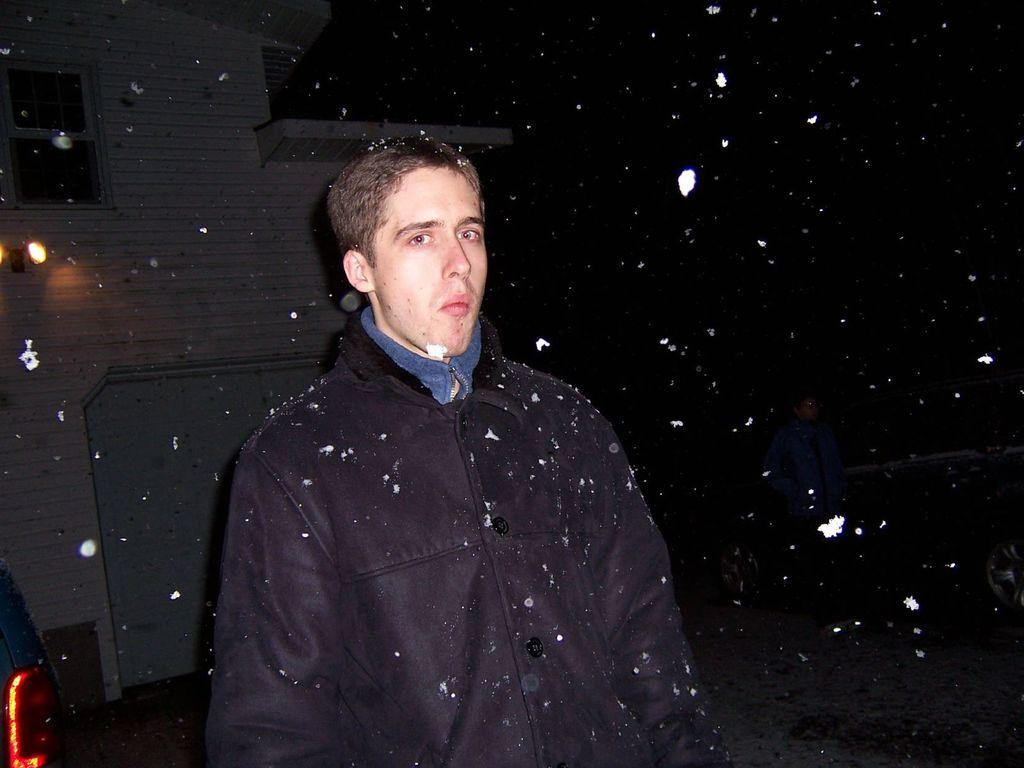Who can be seen in the image? There are people in the image. Can you describe the man in the image? There is a man in the middle of the image. What is located beside the man? There is a car beside the man. What can be seen in the image that provides illumination? There is a light in the image. What type of structure is visible in the image? There is a house in the image. What type of health issues does the tiger in the image have? There is no tiger present in the image, so it is not possible to determine any health issues. 